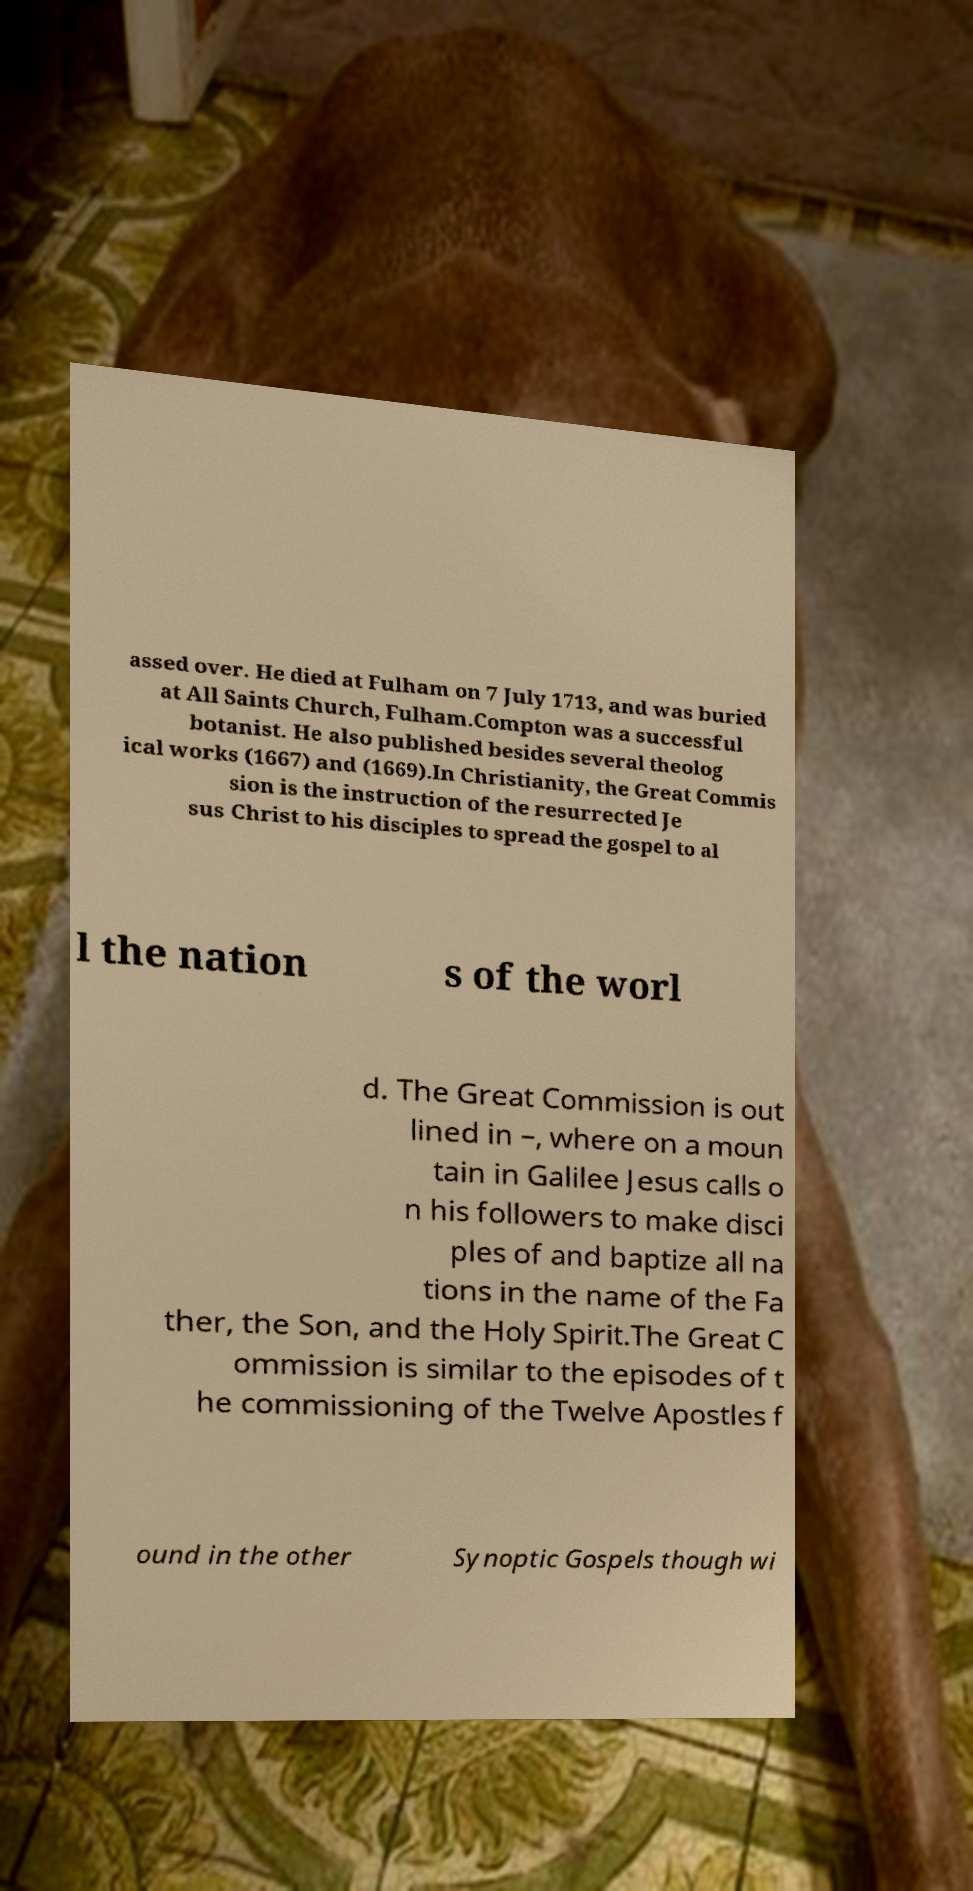Can you read and provide the text displayed in the image?This photo seems to have some interesting text. Can you extract and type it out for me? assed over. He died at Fulham on 7 July 1713, and was buried at All Saints Church, Fulham.Compton was a successful botanist. He also published besides several theolog ical works (1667) and (1669).In Christianity, the Great Commis sion is the instruction of the resurrected Je sus Christ to his disciples to spread the gospel to al l the nation s of the worl d. The Great Commission is out lined in –, where on a moun tain in Galilee Jesus calls o n his followers to make disci ples of and baptize all na tions in the name of the Fa ther, the Son, and the Holy Spirit.The Great C ommission is similar to the episodes of t he commissioning of the Twelve Apostles f ound in the other Synoptic Gospels though wi 